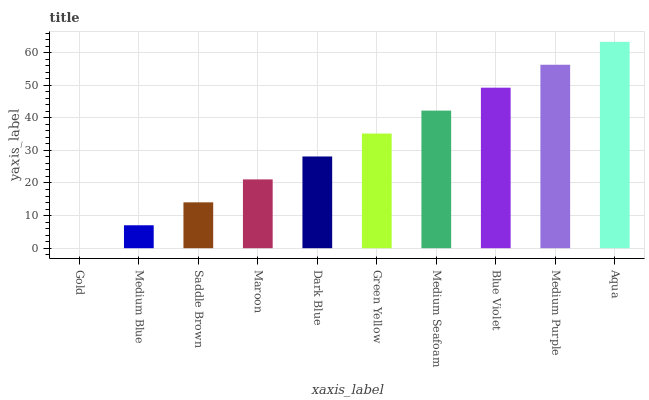Is Gold the minimum?
Answer yes or no. Yes. Is Aqua the maximum?
Answer yes or no. Yes. Is Medium Blue the minimum?
Answer yes or no. No. Is Medium Blue the maximum?
Answer yes or no. No. Is Medium Blue greater than Gold?
Answer yes or no. Yes. Is Gold less than Medium Blue?
Answer yes or no. Yes. Is Gold greater than Medium Blue?
Answer yes or no. No. Is Medium Blue less than Gold?
Answer yes or no. No. Is Green Yellow the high median?
Answer yes or no. Yes. Is Dark Blue the low median?
Answer yes or no. Yes. Is Medium Seafoam the high median?
Answer yes or no. No. Is Aqua the low median?
Answer yes or no. No. 